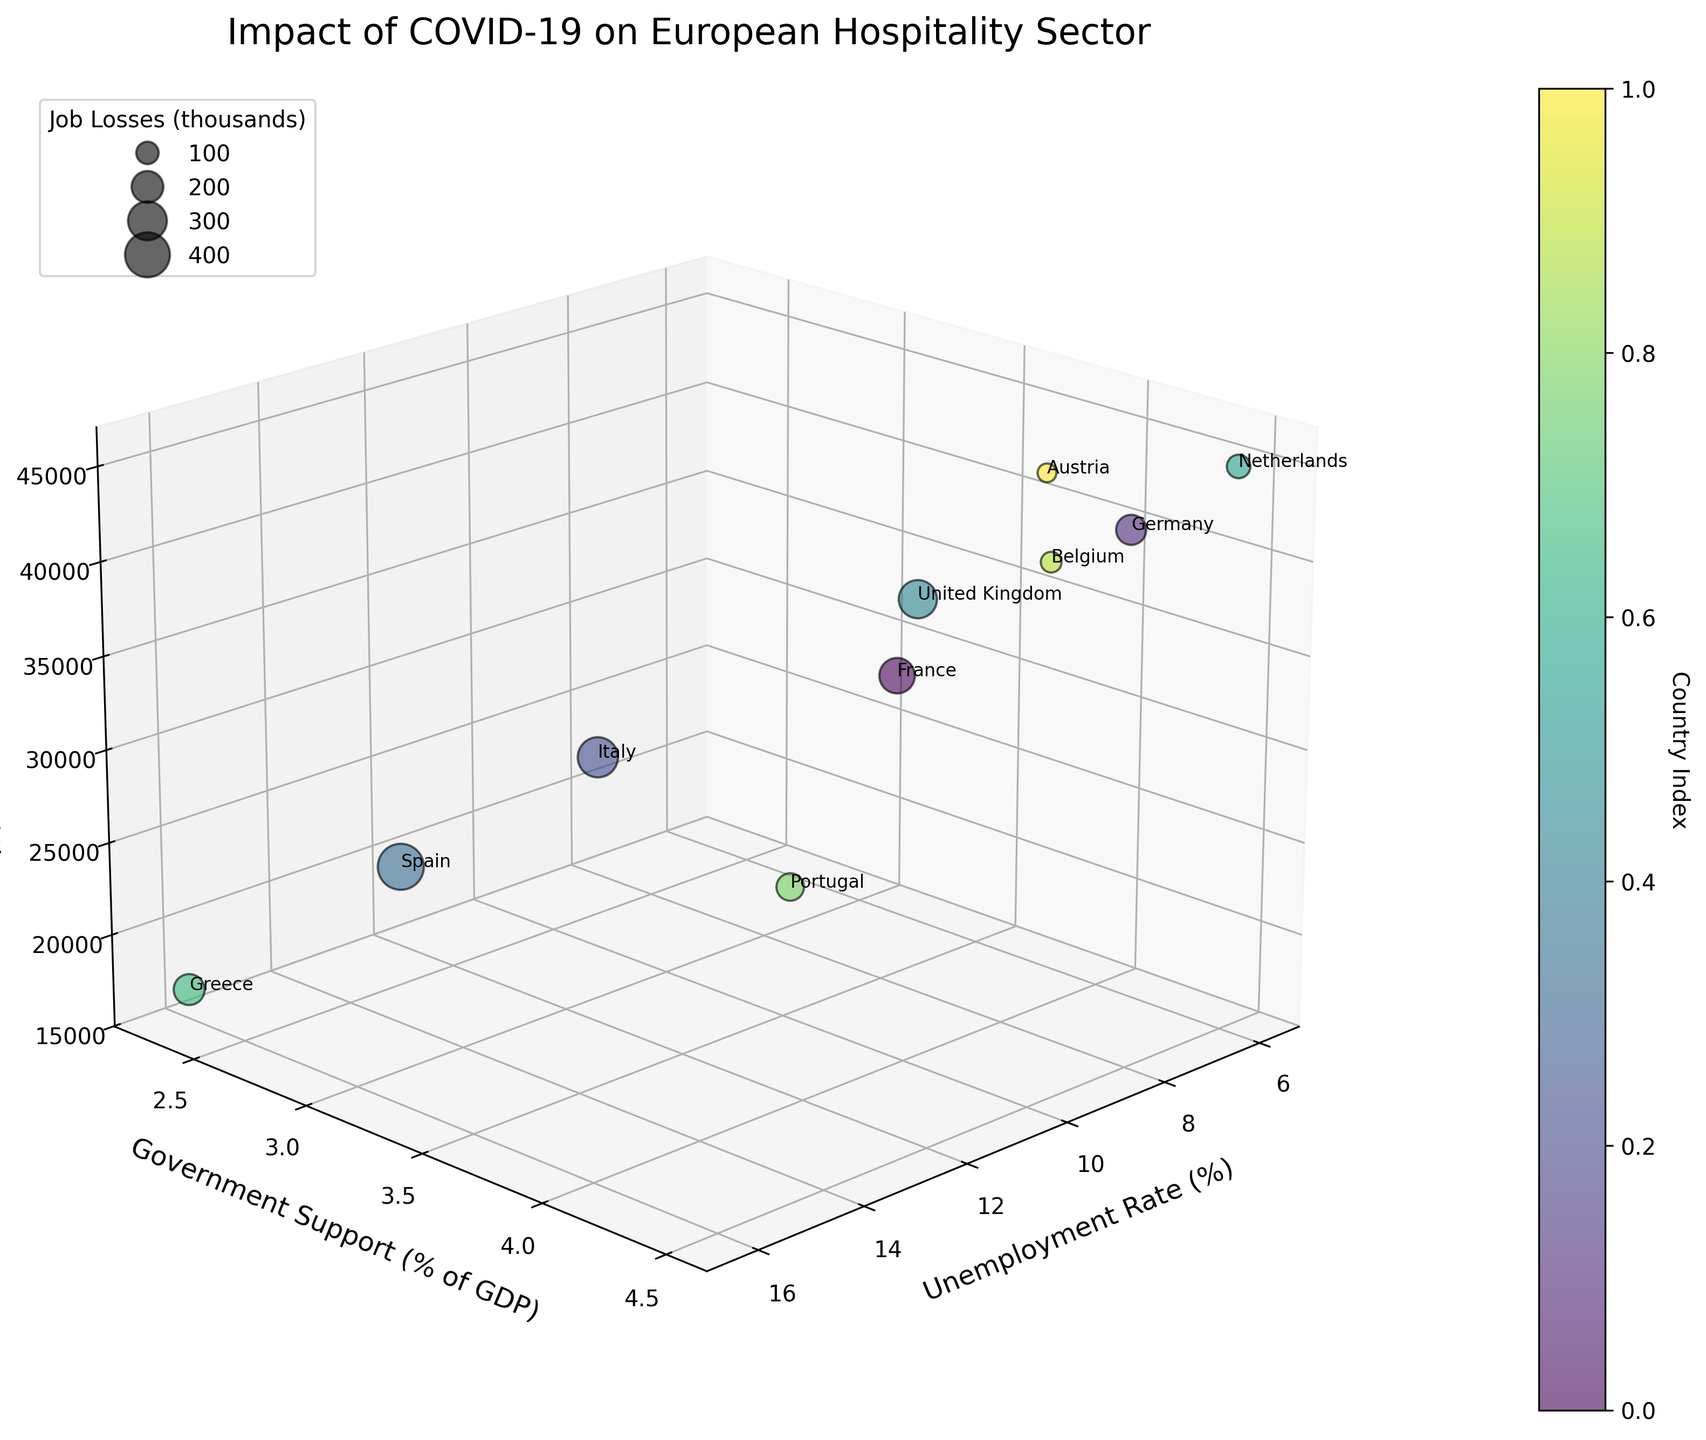How many countries are represented in the 3D bubble chart? Count the number of bubbles on the plot, which corresponds to the number of countries.
Answer: 10 Which country has the highest unemployment rate in the hospitality sector? Locate the bubble on the x-axis with the highest unemployment rate value and check the accompanying text label.
Answer: Greece What is the relationship between government support and GDP per capita for countries with high hospitality job losses? Observe bubbles representing high job losses (larger bubbles) and analyze their positions along the y (Government Support) and z (GDP per Capita) axes.
Answer: No clear trend; varies Which country received the most government support relative to its GDP? Look for the bubble positioned the highest on the y-axis for "Government Support (% of GDP)" and check the label.
Answer: Netherlands Compare France and Germany: which has a higher GDP per capita and how do their unemployment rates differ? Identify the positions of France and Germany on the z-axis for GDP per Capita and the x-axis for Unemployment Rate. France: lower GDP per Capita, higher Unemployment Rate.
Answer: Germany: higher GDP per Capita, France: higher Unemployment Rate What is the total number of hospitality job losses among all countries in the chart? Summing up the hospitality job losses for all countries: 250,000 (France) + 180,000 (Germany) + 320,000 (Italy) + 420,000 (Spain) + 290,000 (UK) + 110,000 (Netherlands) + 190,000 (Greece) + 150,000 (Portugal) + 85,000 (Belgium) + 70,000 (Austria) = 2,065,000
Answer: 2,065,000 Which country with a GDP per capita above €30000 has the lowest unemployment rate? Identify countries with GDP per Capita above €30000 by checking the z-values and then find the one with the lowest x-value for Unemployment Rate.
Answer: Netherlands How does the unemployment rate in Spain compare to that in Italy? Find and compare the x-axis values for Spain and Italy for Unemployment Rate.
Answer: Spain: higher What is the range of government support (% of GDP) among all countries? Locate the minimum and maximum values on the y-axis for "Government Support (% of GDP)" by checking the lowest and highest positions of bubbles. Minimum: 2.3 (Greece), Maximum: 4.5 (Netherlands)
Answer: 2.3 to 4.5 